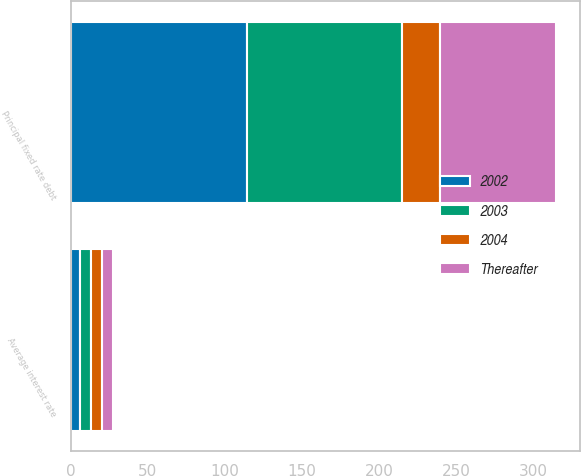<chart> <loc_0><loc_0><loc_500><loc_500><stacked_bar_chart><ecel><fcel>Principal fixed rate debt<fcel>Average interest rate<nl><fcel>2002<fcel>114.5<fcel>6.27<nl><fcel>2003<fcel>100<fcel>6.98<nl><fcel>2004<fcel>25<fcel>7<nl><fcel>Thereafter<fcel>75<fcel>7.12<nl></chart> 